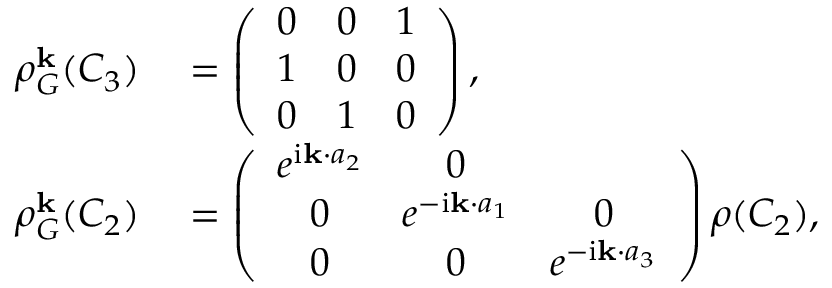<formula> <loc_0><loc_0><loc_500><loc_500>\begin{array} { r l } { \rho _ { G } ^ { k } ( C _ { 3 } ) } & = \left ( \begin{array} { c c c } { 0 } & { 0 } & { 1 } \\ { 1 } & { 0 } & { 0 } \\ { 0 } & { 1 } & { 0 } \end{array} \right ) , } \\ { \rho _ { G } ^ { k } ( C _ { 2 } ) } & = \left ( \begin{array} { c c c } { e ^ { i { k } \cdot { a } _ { 2 } } } & { 0 } \\ { 0 } & { e ^ { - i { k } \cdot { a } _ { 1 } } } & { 0 } \\ { 0 } & { 0 } & { e ^ { - i { k } \cdot { a } _ { 3 } } } \end{array} \right ) \rho ( C _ { 2 } ) , } \end{array}</formula> 